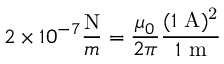Convert formula to latex. <formula><loc_0><loc_0><loc_500><loc_500>{ { 2 } \times 1 0 ^ { - 7 } { \frac { N } { m } } } = { \frac { \mu _ { 0 } } { 2 \pi } } { \frac { ( 1 \ { A ) ^ { 2 } } } { { 1 } \ { m } } }</formula> 